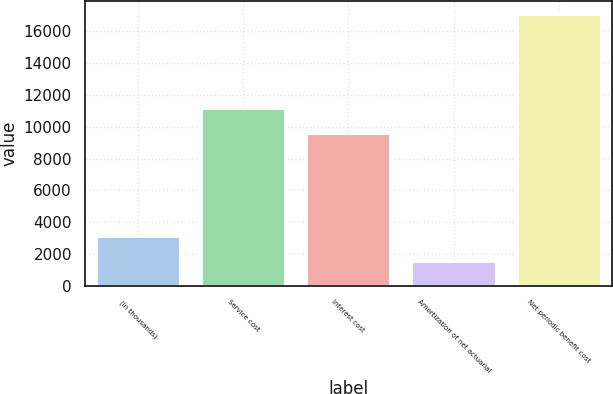<chart> <loc_0><loc_0><loc_500><loc_500><bar_chart><fcel>(in thousands)<fcel>Service cost<fcel>Interest cost<fcel>Amortization of net actuarial<fcel>Net periodic benefit cost<nl><fcel>3132.3<fcel>11181.3<fcel>9633<fcel>1584<fcel>17067<nl></chart> 